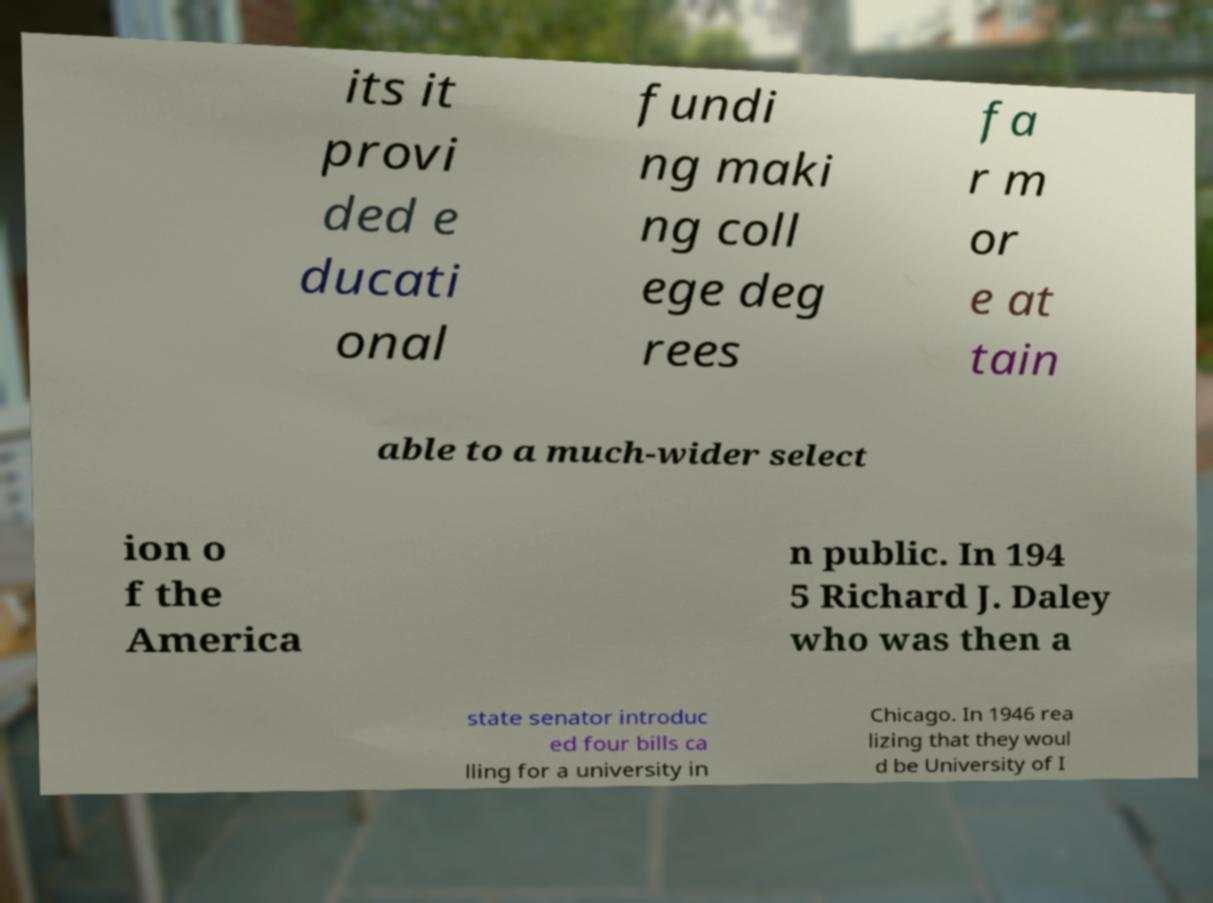For documentation purposes, I need the text within this image transcribed. Could you provide that? its it provi ded e ducati onal fundi ng maki ng coll ege deg rees fa r m or e at tain able to a much-wider select ion o f the America n public. In 194 5 Richard J. Daley who was then a state senator introduc ed four bills ca lling for a university in Chicago. In 1946 rea lizing that they woul d be University of I 